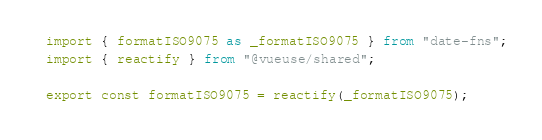<code> <loc_0><loc_0><loc_500><loc_500><_TypeScript_>import { formatISO9075 as _formatISO9075 } from "date-fns";
import { reactify } from "@vueuse/shared";

export const formatISO9075 = reactify(_formatISO9075);</code> 